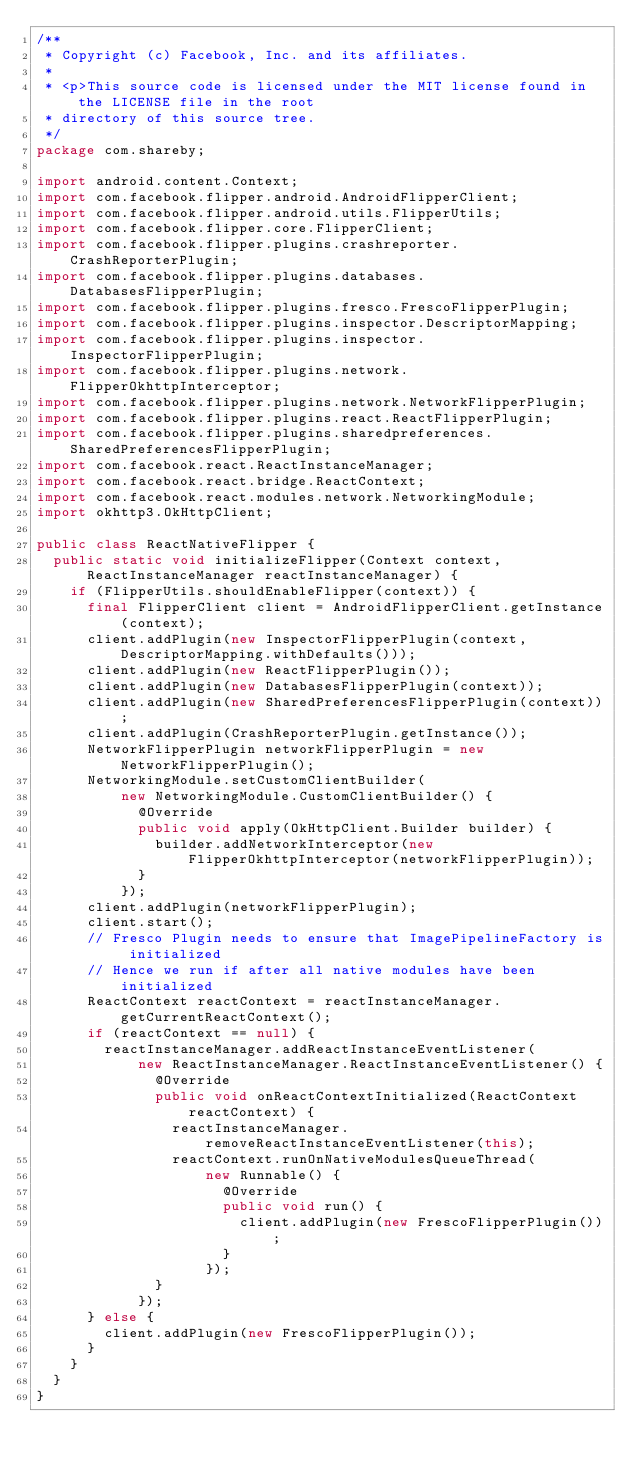Convert code to text. <code><loc_0><loc_0><loc_500><loc_500><_Java_>/**
 * Copyright (c) Facebook, Inc. and its affiliates.
 *
 * <p>This source code is licensed under the MIT license found in the LICENSE file in the root
 * directory of this source tree.
 */
package com.shareby;

import android.content.Context;
import com.facebook.flipper.android.AndroidFlipperClient;
import com.facebook.flipper.android.utils.FlipperUtils;
import com.facebook.flipper.core.FlipperClient;
import com.facebook.flipper.plugins.crashreporter.CrashReporterPlugin;
import com.facebook.flipper.plugins.databases.DatabasesFlipperPlugin;
import com.facebook.flipper.plugins.fresco.FrescoFlipperPlugin;
import com.facebook.flipper.plugins.inspector.DescriptorMapping;
import com.facebook.flipper.plugins.inspector.InspectorFlipperPlugin;
import com.facebook.flipper.plugins.network.FlipperOkhttpInterceptor;
import com.facebook.flipper.plugins.network.NetworkFlipperPlugin;
import com.facebook.flipper.plugins.react.ReactFlipperPlugin;
import com.facebook.flipper.plugins.sharedpreferences.SharedPreferencesFlipperPlugin;
import com.facebook.react.ReactInstanceManager;
import com.facebook.react.bridge.ReactContext;
import com.facebook.react.modules.network.NetworkingModule;
import okhttp3.OkHttpClient;

public class ReactNativeFlipper {
  public static void initializeFlipper(Context context, ReactInstanceManager reactInstanceManager) {
    if (FlipperUtils.shouldEnableFlipper(context)) {
      final FlipperClient client = AndroidFlipperClient.getInstance(context);
      client.addPlugin(new InspectorFlipperPlugin(context, DescriptorMapping.withDefaults()));
      client.addPlugin(new ReactFlipperPlugin());
      client.addPlugin(new DatabasesFlipperPlugin(context));
      client.addPlugin(new SharedPreferencesFlipperPlugin(context));
      client.addPlugin(CrashReporterPlugin.getInstance());
      NetworkFlipperPlugin networkFlipperPlugin = new NetworkFlipperPlugin();
      NetworkingModule.setCustomClientBuilder(
          new NetworkingModule.CustomClientBuilder() {
            @Override
            public void apply(OkHttpClient.Builder builder) {
              builder.addNetworkInterceptor(new FlipperOkhttpInterceptor(networkFlipperPlugin));
            }
          });
      client.addPlugin(networkFlipperPlugin);
      client.start();
      // Fresco Plugin needs to ensure that ImagePipelineFactory is initialized
      // Hence we run if after all native modules have been initialized
      ReactContext reactContext = reactInstanceManager.getCurrentReactContext();
      if (reactContext == null) {
        reactInstanceManager.addReactInstanceEventListener(
            new ReactInstanceManager.ReactInstanceEventListener() {
              @Override
              public void onReactContextInitialized(ReactContext reactContext) {
                reactInstanceManager.removeReactInstanceEventListener(this);
                reactContext.runOnNativeModulesQueueThread(
                    new Runnable() {
                      @Override
                      public void run() {
                        client.addPlugin(new FrescoFlipperPlugin());
                      }
                    });
              }
            });
      } else {
        client.addPlugin(new FrescoFlipperPlugin());
      }
    }
  }
}</code> 